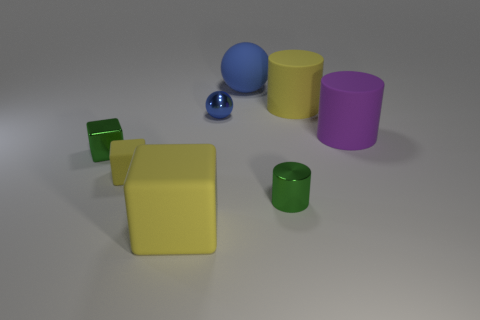Subtract all large yellow matte blocks. How many blocks are left? 2 Subtract all green balls. How many yellow blocks are left? 2 Add 1 small blue metallic spheres. How many objects exist? 9 Subtract 1 cylinders. How many cylinders are left? 2 Subtract 0 cyan cubes. How many objects are left? 8 Subtract all cylinders. How many objects are left? 5 Subtract all green cylinders. Subtract all yellow spheres. How many cylinders are left? 2 Subtract all large gray shiny balls. Subtract all large balls. How many objects are left? 7 Add 6 tiny metal balls. How many tiny metal balls are left? 7 Add 3 small green blocks. How many small green blocks exist? 4 